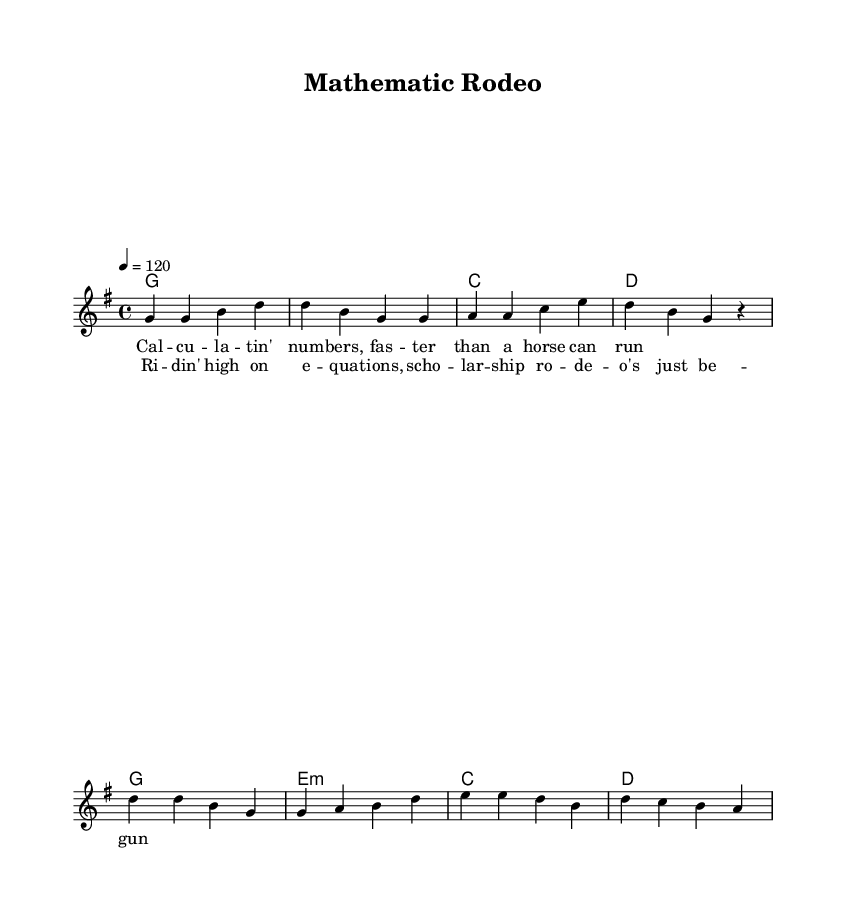What is the key signature of this music? The key signature is G major, which has one sharp (F#). We can determine this by looking at the key signature notation at the beginning of the score.
Answer: G major What is the time signature of this music? The time signature is 4/4, which is indicated at the beginning of the score. This means there are four beats in each measure and the quarter note gets one beat.
Answer: 4/4 What is the tempo marking in this piece? The tempo marking is given as 4 = 120, which indicates that there are 120 beats per minute. This helps performers to understand how fast to play the piece.
Answer: 120 How many measures are present in the chorus? There are four measures in the chorus section, which can be counted directly from the notation of the chorus melody and harmonies.
Answer: 4 What is the chord for the first measure of the verse? The chord for the first measure of the verse is G major, noted at the beginning of the harmonies section where G is indicated alone, representing a whole note.
Answer: G What word is repeated in the chorus lyrics? The word "rodeo" is repeated in the chorus lyrics, as indicated in the lyrics section where it appears at the end of the phrase.
Answer: rodeo What academic themes are celebrated in this song? The song celebrates themes of mathematics and scholarship, as reflected in the lyrics such as "calculatin' numbers" and "scholarship rodeo."
Answer: mathematics and scholarship 